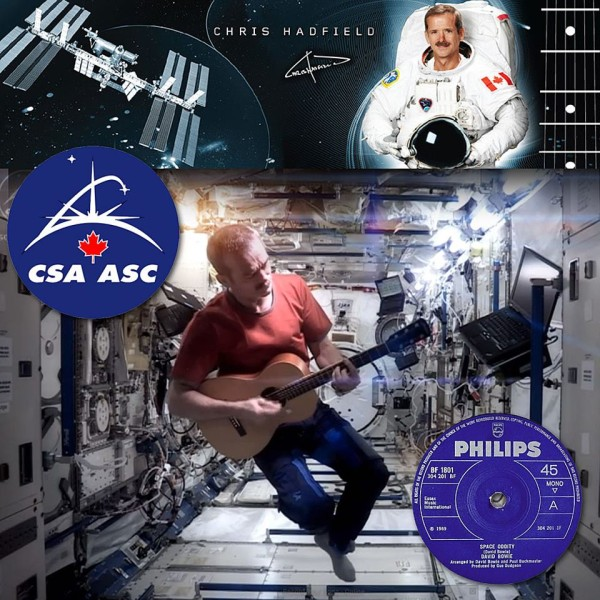What does the song 'Space Oddity' symbolize in the context of human space exploration? In the context of human space exploration, 'Space Oddity' transcends its role as a song to become a cultural symbol. Written at the dawn of the space age, its lyrics poignantly capture the awe and uncertainty surrounding human venturing into space. The song's narrative, centered on Major Tom's solitary voyage, reflects the psychological realities of astronauts who face both the thrill of exploration and the isolation of space. It resonates deeply with astronauts like Chris Hadfield, who have lived these experiences, making it a fitting anthem for the endeavors of human spaceflight. 